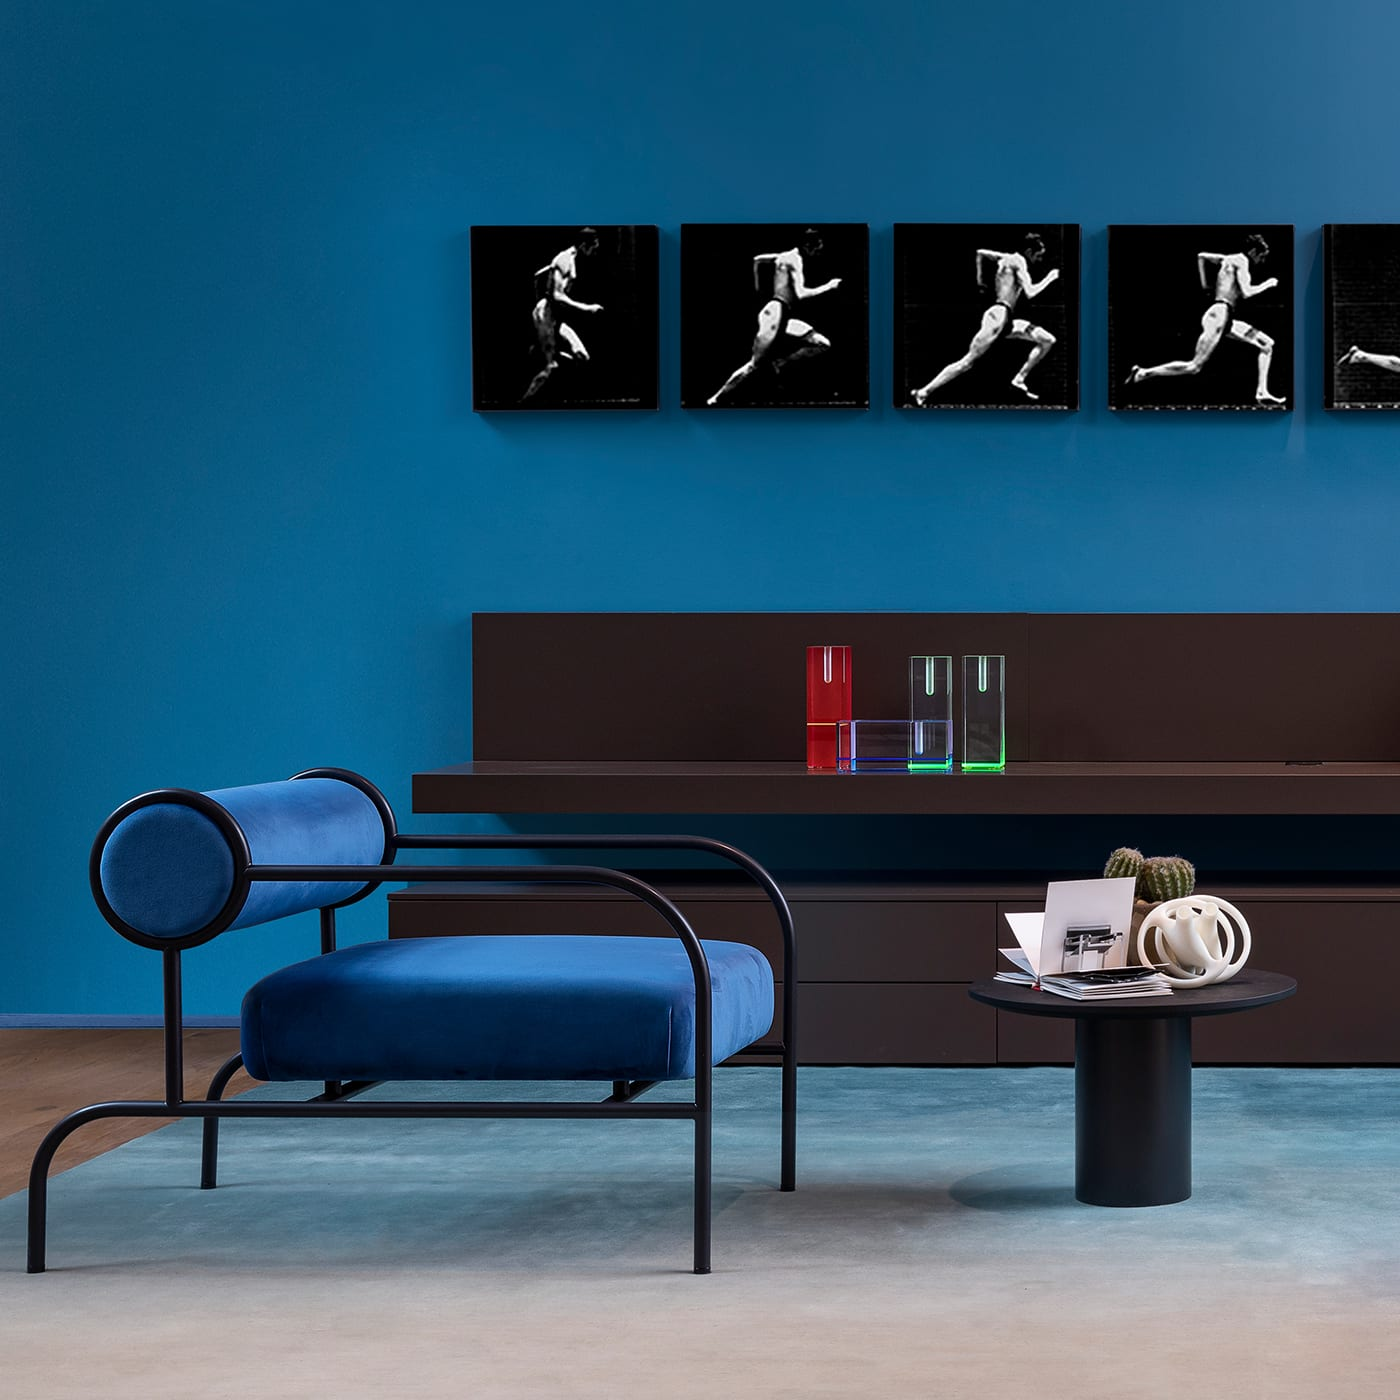How many chairs are there in the image? 1 